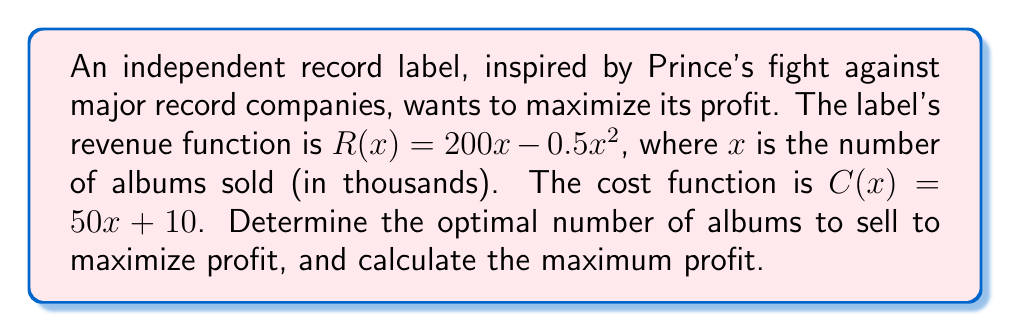Can you answer this question? 1) The profit function $P(x)$ is the difference between revenue $R(x)$ and cost $C(x)$:
   $P(x) = R(x) - C(x) = (200x - 0.5x^2) - (50x + 10)$
   $P(x) = 200x - 0.5x^2 - 50x - 10$
   $P(x) = 150x - 0.5x^2 - 10$

2) To find the maximum profit, we need to find where the derivative of $P(x)$ equals zero:
   $\frac{d}{dx}P(x) = 150 - x$
   Set this equal to zero: $150 - x = 0$
   Solve for $x$: $x = 150$

3) To confirm this is a maximum, check the second derivative:
   $\frac{d^2}{dx^2}P(x) = -1 < 0$, confirming a maximum.

4) The optimal number of albums to sell is 150 thousand.

5) Calculate the maximum profit by plugging $x = 150$ into $P(x)$:
   $P(150) = 150(150) - 0.5(150)^2 - 10$
   $= 22,500 - 11,250 - 10 = 11,240$

Therefore, the maximum profit is $11,240 thousand, or $11,240,000.
Answer: Optimal number of albums: 150,000; Maximum profit: $11,240,000 